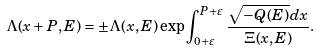<formula> <loc_0><loc_0><loc_500><loc_500>\Lambda ( x + P , E ) = \pm \Lambda ( x , E ) \exp \int _ { 0 + \varepsilon } ^ { P + \varepsilon } \frac { \sqrt { - Q ( E ) } d x } { \Xi ( x , E ) } .</formula> 